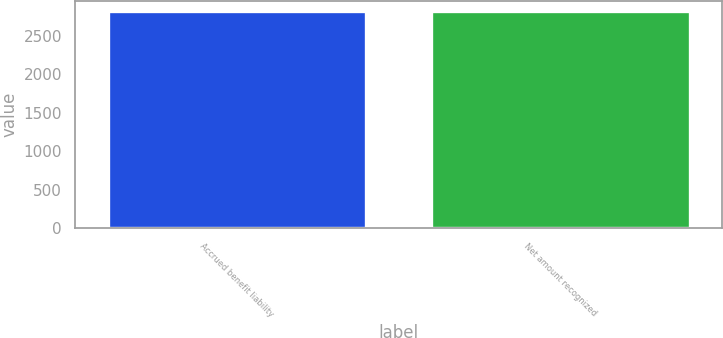Convert chart to OTSL. <chart><loc_0><loc_0><loc_500><loc_500><bar_chart><fcel>Accrued benefit liability<fcel>Net amount recognized<nl><fcel>2817<fcel>2817.1<nl></chart> 